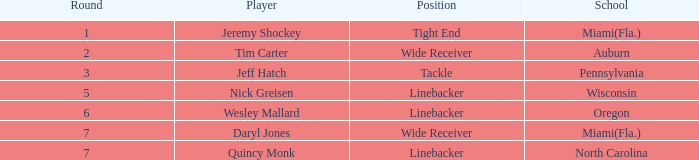Can you give me this table as a dict? {'header': ['Round', 'Player', 'Position', 'School'], 'rows': [['1', 'Jeremy Shockey', 'Tight End', 'Miami(Fla.)'], ['2', 'Tim Carter', 'Wide Receiver', 'Auburn'], ['3', 'Jeff Hatch', 'Tackle', 'Pennsylvania'], ['5', 'Nick Greisen', 'Linebacker', 'Wisconsin'], ['6', 'Wesley Mallard', 'Linebacker', 'Oregon'], ['7', 'Daryl Jones', 'Wide Receiver', 'Miami(Fla.)'], ['7', 'Quincy Monk', 'Linebacker', 'North Carolina']]} From what school was the player drafted in round 3? Pennsylvania. 